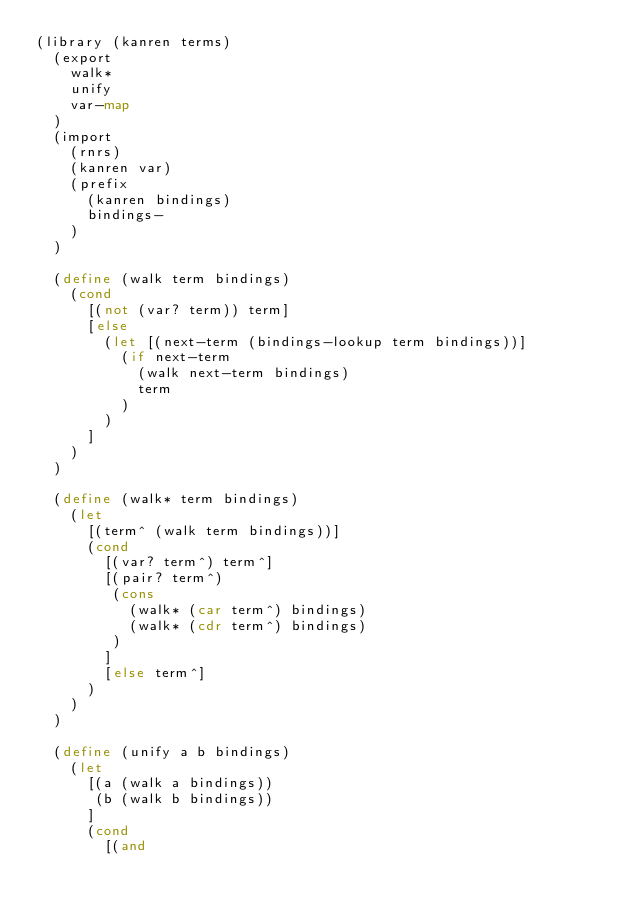<code> <loc_0><loc_0><loc_500><loc_500><_Scheme_>(library (kanren terms)
  (export
    walk*
    unify
    var-map
  )
  (import
    (rnrs)
    (kanren var)
    (prefix
      (kanren bindings)
      bindings-
    )
  )

  (define (walk term bindings)
    (cond
      [(not (var? term)) term]
      [else
        (let [(next-term (bindings-lookup term bindings))]
          (if next-term
            (walk next-term bindings)
            term
          )
        )
      ]
    )
  )

  (define (walk* term bindings)
    (let
      [(term^ (walk term bindings))]
      (cond
        [(var? term^) term^]
        [(pair? term^)
         (cons
           (walk* (car term^) bindings)
           (walk* (cdr term^) bindings)
         )
        ]
        [else term^]
      )
    )
  )

  (define (unify a b bindings)
    (let
      [(a (walk a bindings))
       (b (walk b bindings))
      ]
      (cond
        [(and</code> 